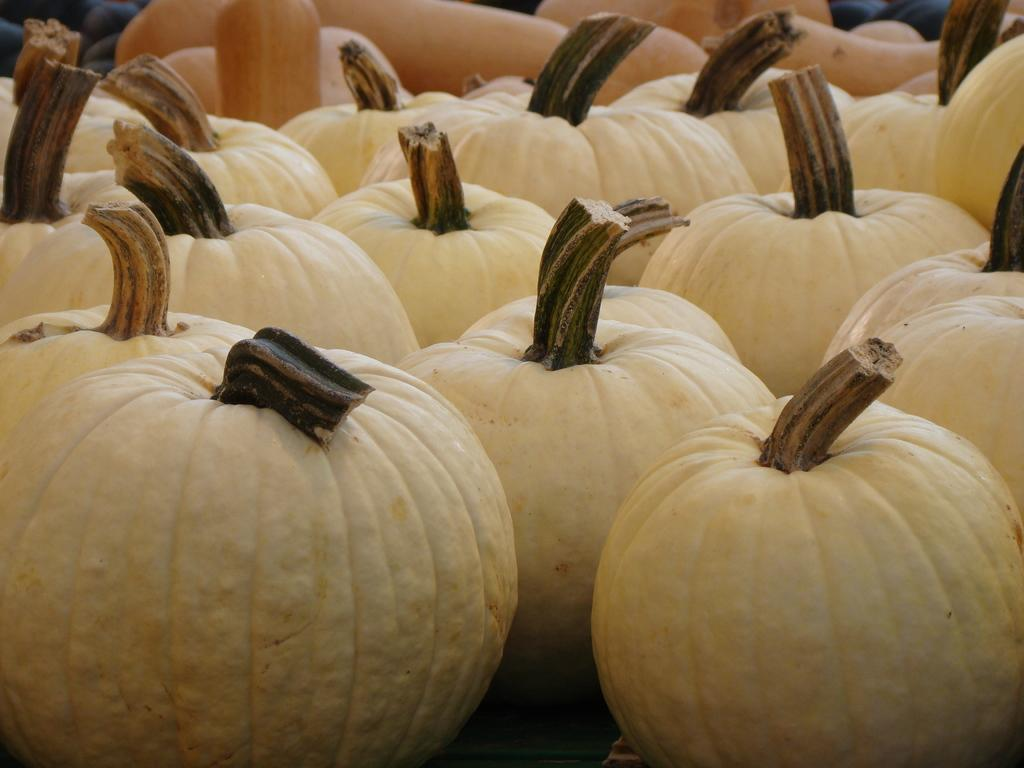What type of vegetable is present in the image? There are pumpkins in the image. Can you describe the objects visible at the top of the image? Unfortunately, there is not enough information provided to describe the objects visible at the top of the image. How many members of the family are visible in the image? There is no family present in the image; it only features pumpkins. What type of line can be seen connecting the pumpkins in the image? There is no line connecting the pumpkins in the image; they are not arranged in a specific pattern. 